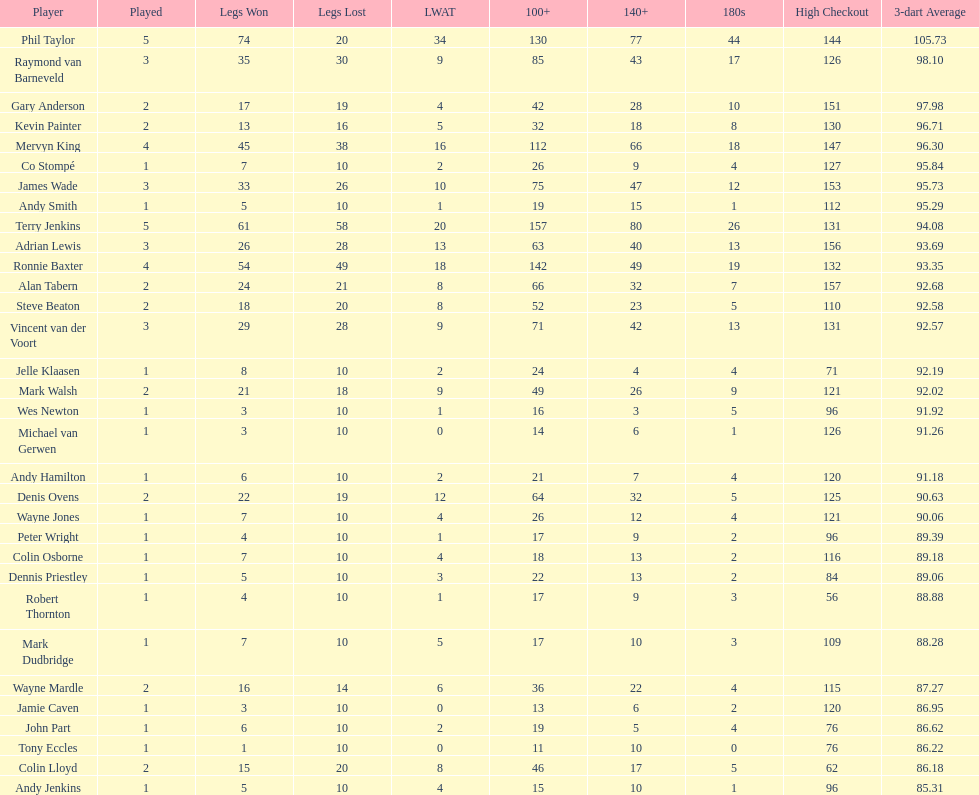How many players hold a 3-dart average above 97? 3. 